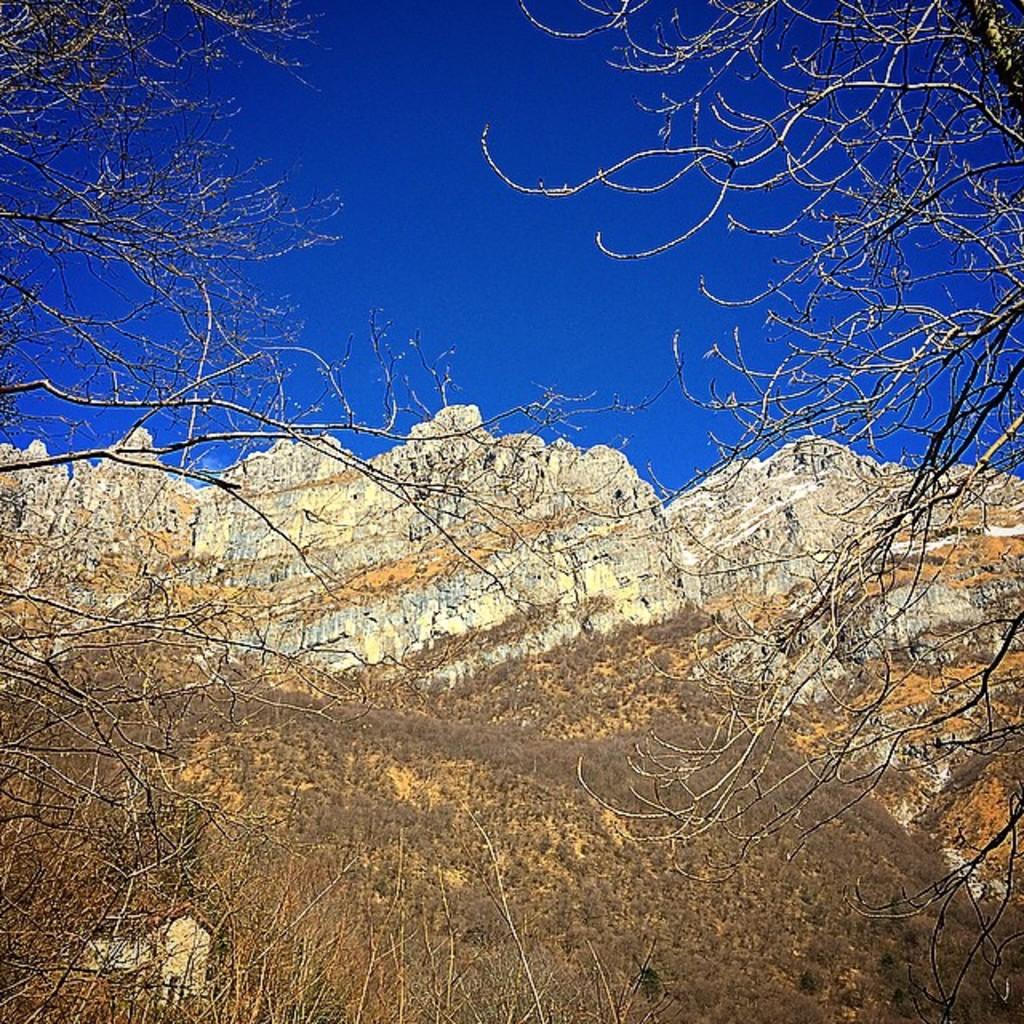What type of vegetation can be seen in the image? There are trees in the image. What type of landscape feature is visible in the image? There are hills visible in the image. What color is the sky in the image? The sky is blue in the image. Where is the sack located in the image? There is no sack present in the image. What type of insect can be seen flying around the trees in the image? There are no insects visible in the image, so it is not possible to determine if any are present. 